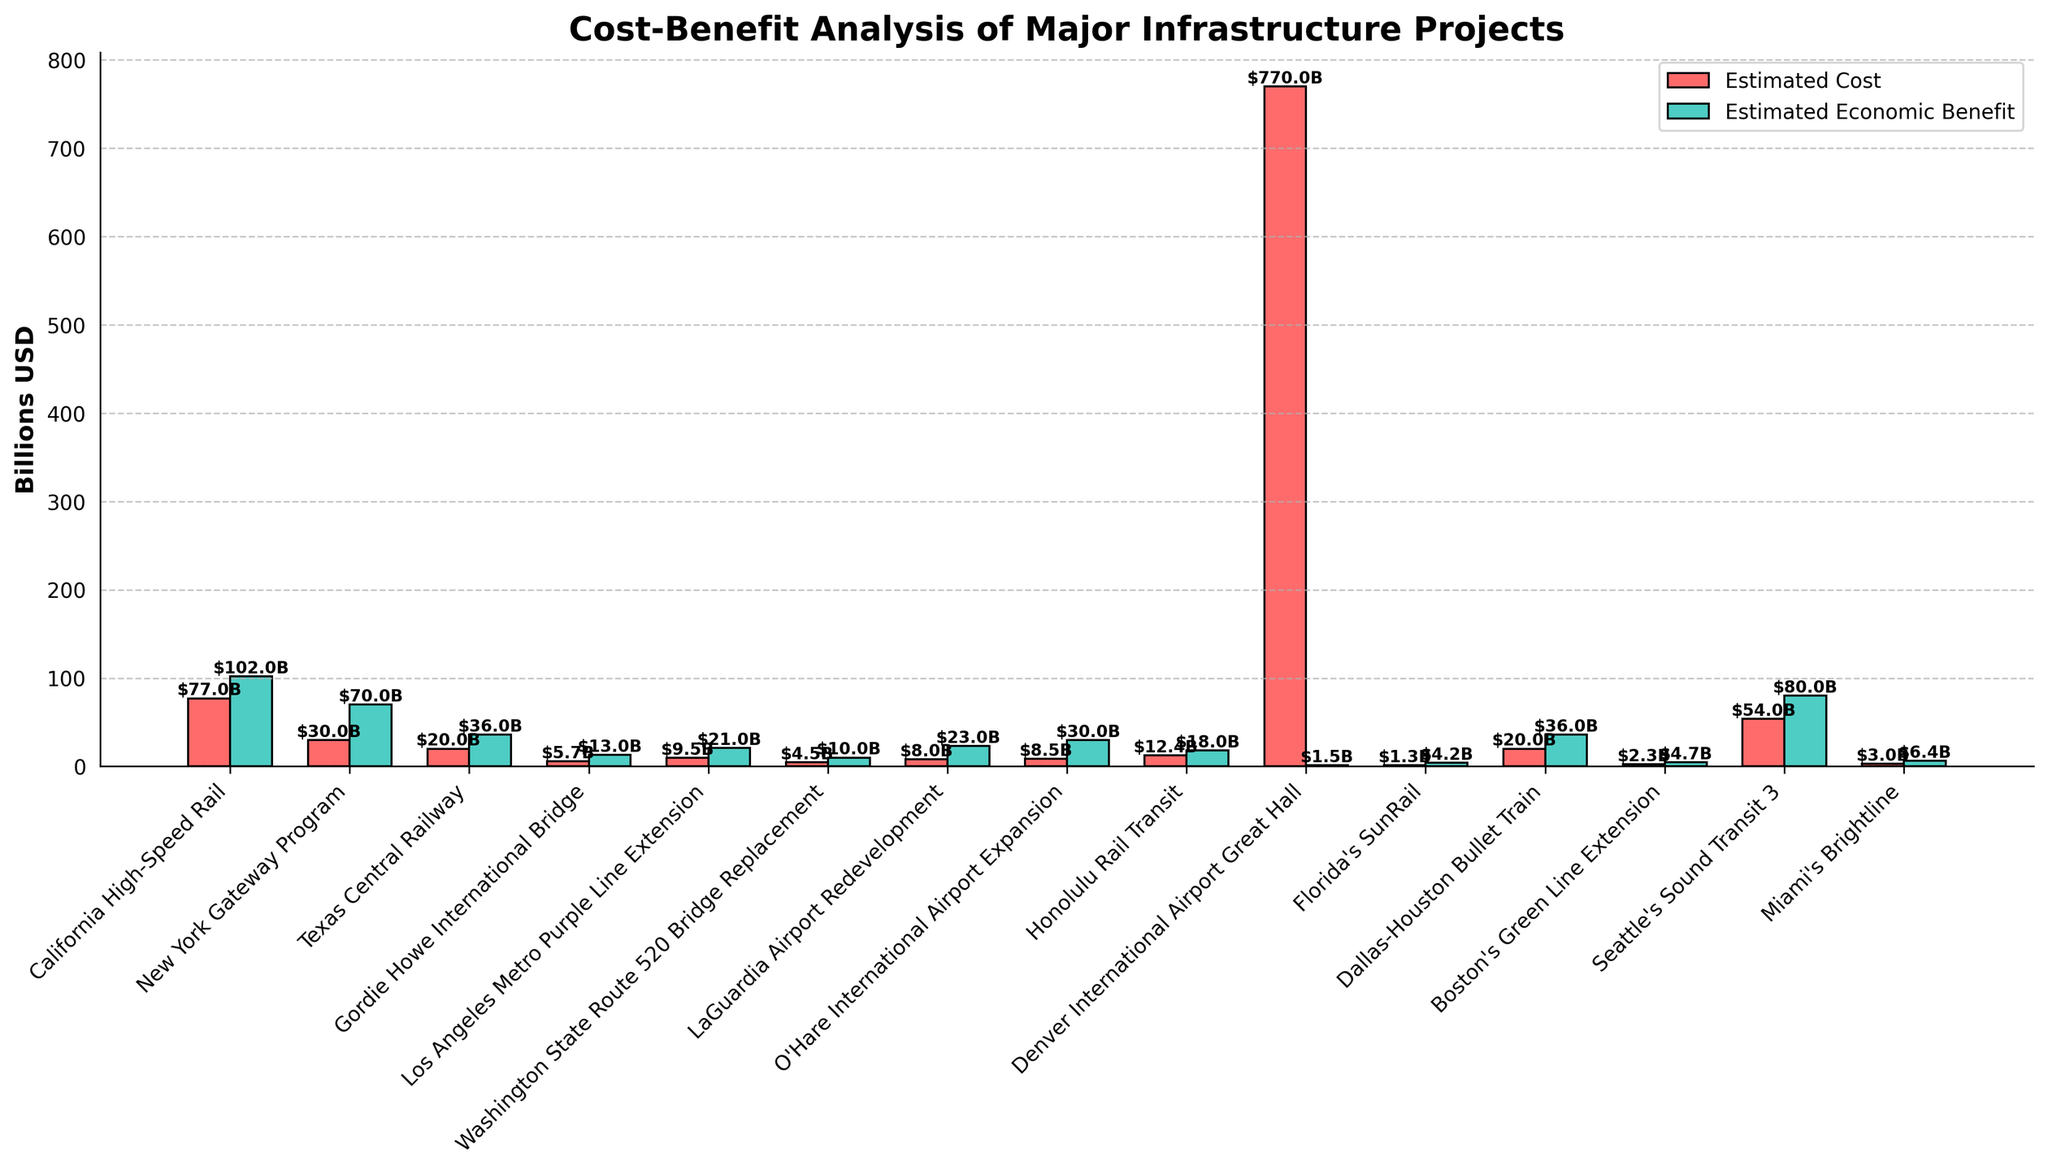Which project has the highest estimated cost? The bar representing the California High-Speed Rail is the tallest among the red bars, indicating the highest estimated cost.
Answer: California High-Speed Rail Which project has the highest estimated economic benefit? The bar representing the California High-Speed Rail is the tallest among the green bars, indicating the highest estimated economic benefit.
Answer: California High-Speed Rail What is the difference in estimated economic benefit between the New York Gateway Program and the Texas Central Railway? The estimated economic benefit for the New York Gateway Program is 70 billion USD and for the Texas Central Railway is 36 billion USD. The difference is 70 - 36.
Answer: 34 billion USD Which project has a higher ratio of estimated economic benefit to estimated cost, the Honolulu Rail Transit or the LaGuardia Airport Redevelopment? The ratio for the Honolulu Rail Transit is 18/12.4, and for the LaGuardia Airport Redevelopment is 23/8. Both ratios should be calculated and compared.
Answer: LaGuardia Airport Redevelopment What is the combined estimated cost of the Boston's Green Line Extension and Miami's Brightline projects? The estimated costs are 2.3 billion USD for Boston's Green Line Extension and 3 billion USD for Miami's Brightline. Sum these costs: 2.3 + 3.
Answer: 5.3 billion USD Which project has the smallest difference between its estimated cost and economic benefit? Calculate the absolute difference between the cost and benefit for each project and compare them. The smallest difference is 0.8 billion USD for the Boston's Green Line Extension.
Answer: Boston's Green Line Extension How does the estimated cost of the Dallas-Houston Bullet Train compare to the Texas Central Railway? Both bars for these projects have the same height for estimated cost, indicating they are equal.
Answer: Equal Identify a project with an estimated economic benefit that is more than double its estimated cost. Identify projects where the green bar is more than twice the height of the red bar. The New York Gateway Program with benefits of 70 billion USD and costs of 30 billion USD fits this criterion.
Answer: New York Gateway Program What is the total estimated economic benefit of projects with an estimated cost exceeding 50 billion USD? The eligible projects are the California High-Speed Rail and Seattle's Sound Transit 3. The benefits are 102 billion USD and 80 billion USD respectively. Sum these benefits: 102 + 80.
Answer: 182 billion USD 